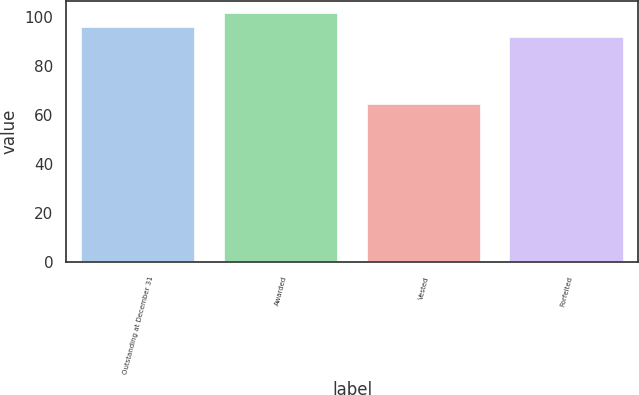<chart> <loc_0><loc_0><loc_500><loc_500><bar_chart><fcel>Outstanding at December 31<fcel>Awarded<fcel>Vested<fcel>Forfeited<nl><fcel>95.72<fcel>101.5<fcel>64.63<fcel>92.03<nl></chart> 